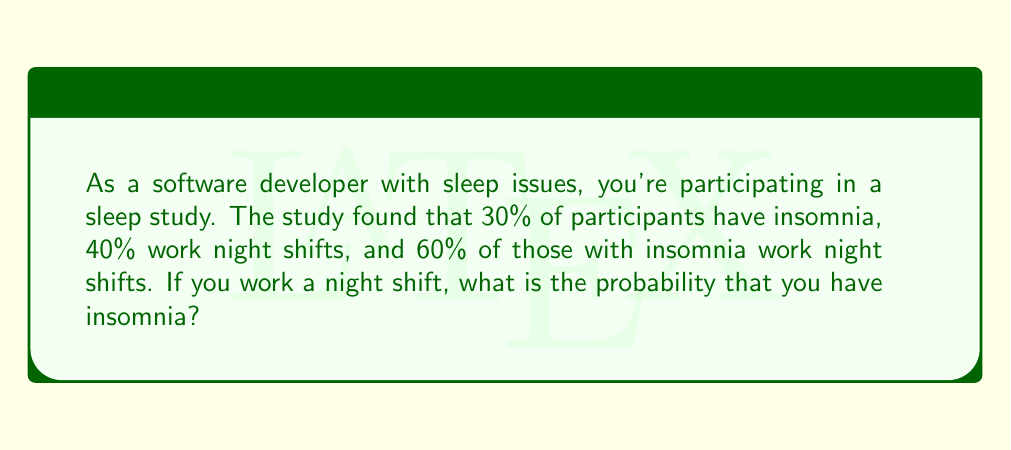Can you answer this question? Let's approach this problem using conditional probability. We'll use the following notation:

$I$: Event of having insomnia
$N$: Event of working night shifts

Given:
$P(I) = 0.30$ (30% have insomnia)
$P(N) = 0.40$ (40% work night shifts)
$P(N|I) = 0.60$ (60% of those with insomnia work night shifts)

We need to find $P(I|N)$, the probability of having insomnia given that you work night shifts.

We can use Bayes' theorem:

$$P(I|N) = \frac{P(N|I) \cdot P(I)}{P(N)}$$

We know $P(N|I)$, $P(I)$, and $P(N)$. Let's substitute these values:

$$P(I|N) = \frac{0.60 \cdot 0.30}{0.40}$$

Simplifying:

$$P(I|N) = \frac{0.18}{0.40} = 0.45$$

Therefore, the probability of having insomnia given that you work night shifts is 0.45 or 45%.
Answer: $P(I|N) = 0.45$ or 45% 